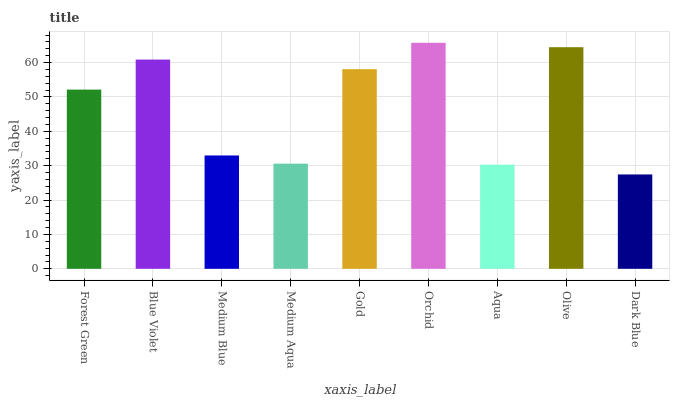Is Dark Blue the minimum?
Answer yes or no. Yes. Is Orchid the maximum?
Answer yes or no. Yes. Is Blue Violet the minimum?
Answer yes or no. No. Is Blue Violet the maximum?
Answer yes or no. No. Is Blue Violet greater than Forest Green?
Answer yes or no. Yes. Is Forest Green less than Blue Violet?
Answer yes or no. Yes. Is Forest Green greater than Blue Violet?
Answer yes or no. No. Is Blue Violet less than Forest Green?
Answer yes or no. No. Is Forest Green the high median?
Answer yes or no. Yes. Is Forest Green the low median?
Answer yes or no. Yes. Is Gold the high median?
Answer yes or no. No. Is Orchid the low median?
Answer yes or no. No. 